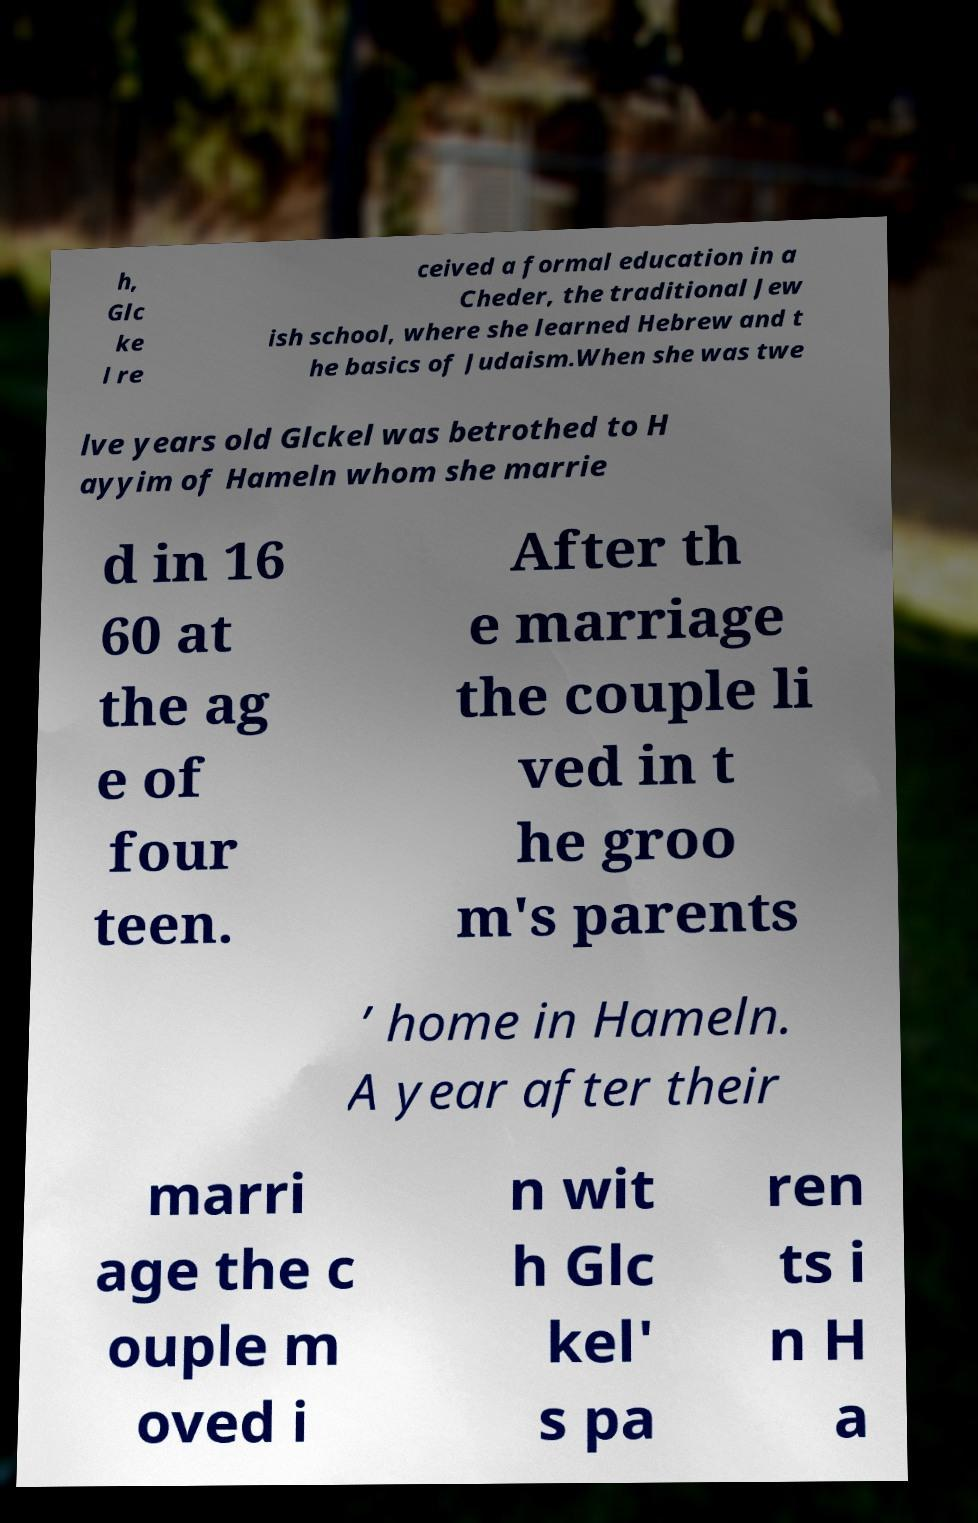Can you accurately transcribe the text from the provided image for me? h, Glc ke l re ceived a formal education in a Cheder, the traditional Jew ish school, where she learned Hebrew and t he basics of Judaism.When she was twe lve years old Glckel was betrothed to H ayyim of Hameln whom she marrie d in 16 60 at the ag e of four teen. After th e marriage the couple li ved in t he groo m's parents ’ home in Hameln. A year after their marri age the c ouple m oved i n wit h Glc kel' s pa ren ts i n H a 